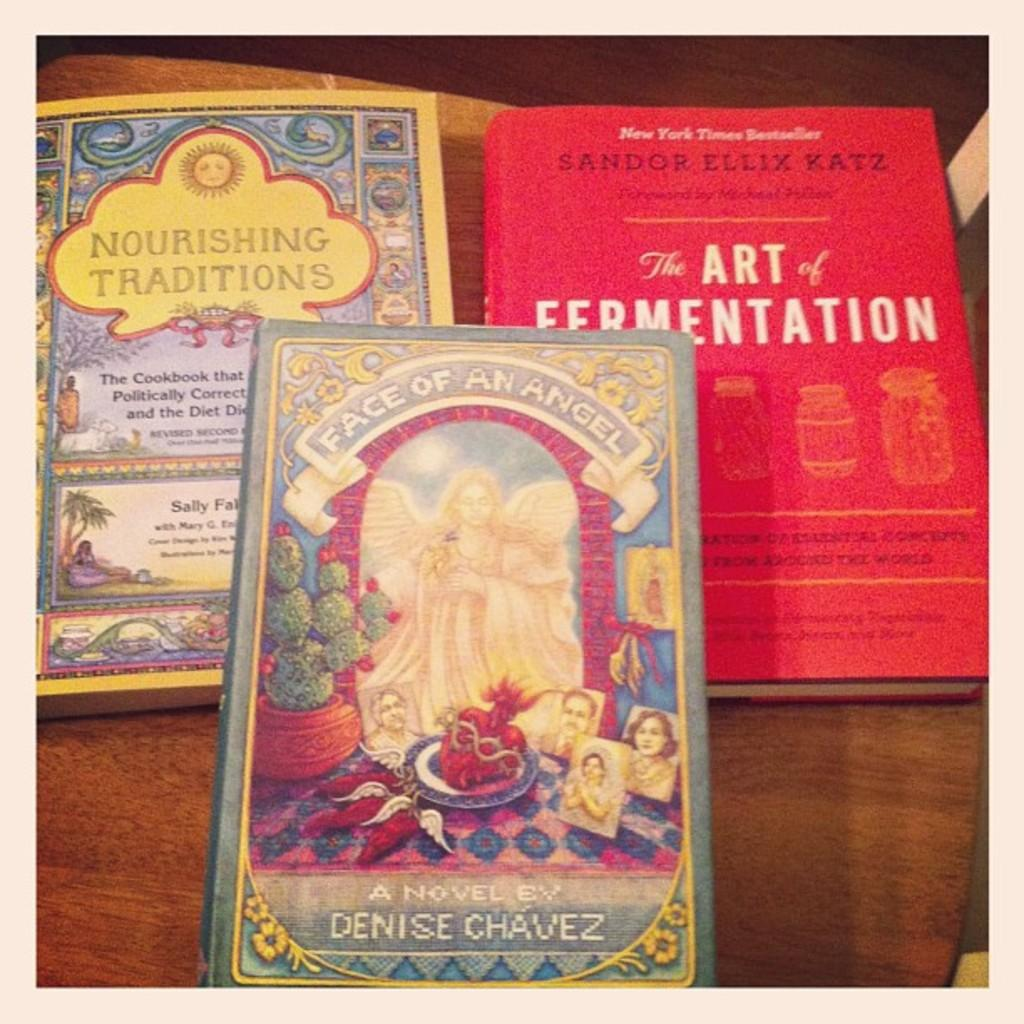<image>
Write a terse but informative summary of the picture. Three books including The Art of Fermentation and Face of An Angel. 